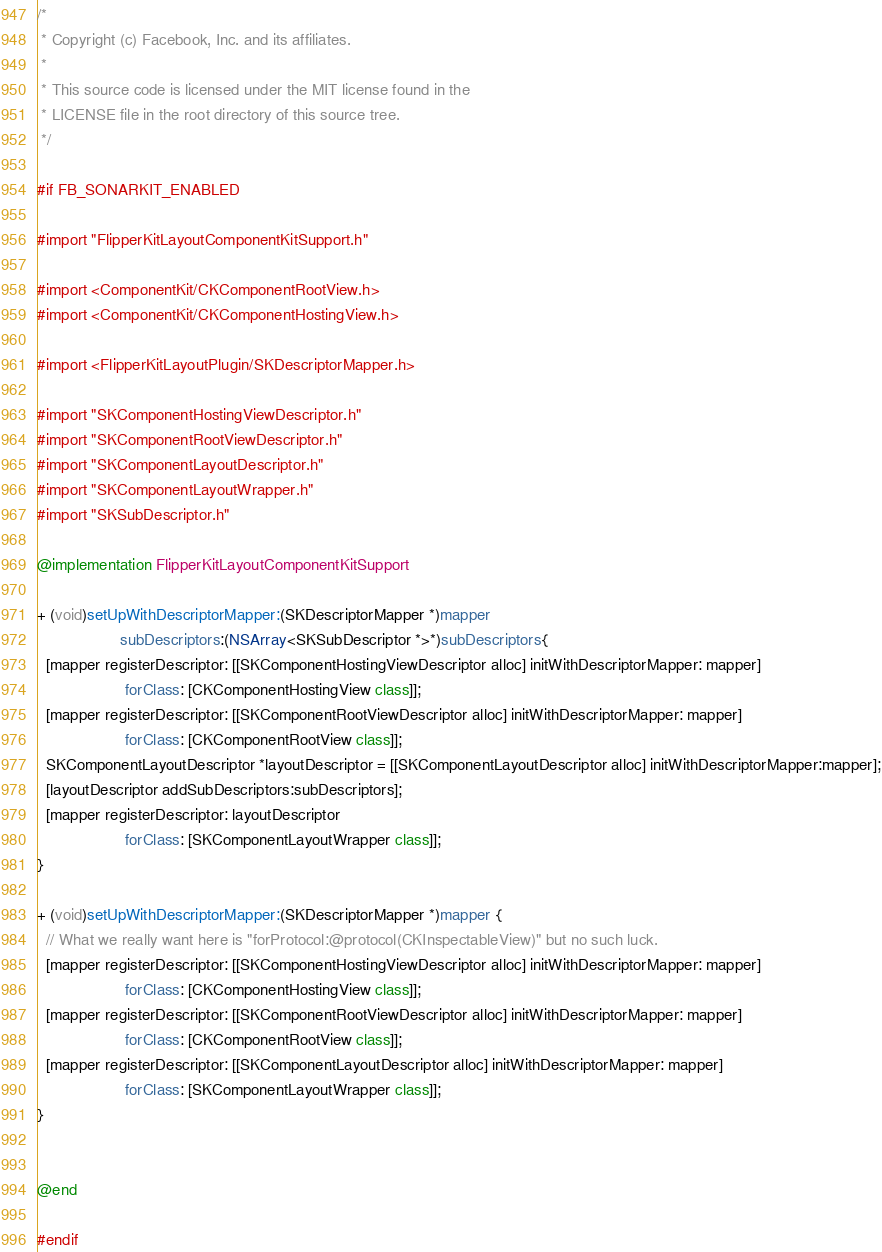<code> <loc_0><loc_0><loc_500><loc_500><_ObjectiveC_>/*
 * Copyright (c) Facebook, Inc. and its affiliates.
 *
 * This source code is licensed under the MIT license found in the
 * LICENSE file in the root directory of this source tree.
 */

#if FB_SONARKIT_ENABLED

#import "FlipperKitLayoutComponentKitSupport.h"

#import <ComponentKit/CKComponentRootView.h>
#import <ComponentKit/CKComponentHostingView.h>

#import <FlipperKitLayoutPlugin/SKDescriptorMapper.h>

#import "SKComponentHostingViewDescriptor.h"
#import "SKComponentRootViewDescriptor.h"
#import "SKComponentLayoutDescriptor.h"
#import "SKComponentLayoutWrapper.h"
#import "SKSubDescriptor.h"

@implementation FlipperKitLayoutComponentKitSupport

+ (void)setUpWithDescriptorMapper:(SKDescriptorMapper *)mapper
                   subDescriptors:(NSArray<SKSubDescriptor *>*)subDescriptors{
  [mapper registerDescriptor: [[SKComponentHostingViewDescriptor alloc] initWithDescriptorMapper: mapper]
                    forClass: [CKComponentHostingView class]];
  [mapper registerDescriptor: [[SKComponentRootViewDescriptor alloc] initWithDescriptorMapper: mapper]
                    forClass: [CKComponentRootView class]];
  SKComponentLayoutDescriptor *layoutDescriptor = [[SKComponentLayoutDescriptor alloc] initWithDescriptorMapper:mapper];
  [layoutDescriptor addSubDescriptors:subDescriptors];
  [mapper registerDescriptor: layoutDescriptor
                    forClass: [SKComponentLayoutWrapper class]];
}

+ (void)setUpWithDescriptorMapper:(SKDescriptorMapper *)mapper {
  // What we really want here is "forProtocol:@protocol(CKInspectableView)" but no such luck.
  [mapper registerDescriptor: [[SKComponentHostingViewDescriptor alloc] initWithDescriptorMapper: mapper]
                    forClass: [CKComponentHostingView class]];
  [mapper registerDescriptor: [[SKComponentRootViewDescriptor alloc] initWithDescriptorMapper: mapper]
                    forClass: [CKComponentRootView class]];
  [mapper registerDescriptor: [[SKComponentLayoutDescriptor alloc] initWithDescriptorMapper: mapper]
                    forClass: [SKComponentLayoutWrapper class]];
}


@end

#endif
</code> 